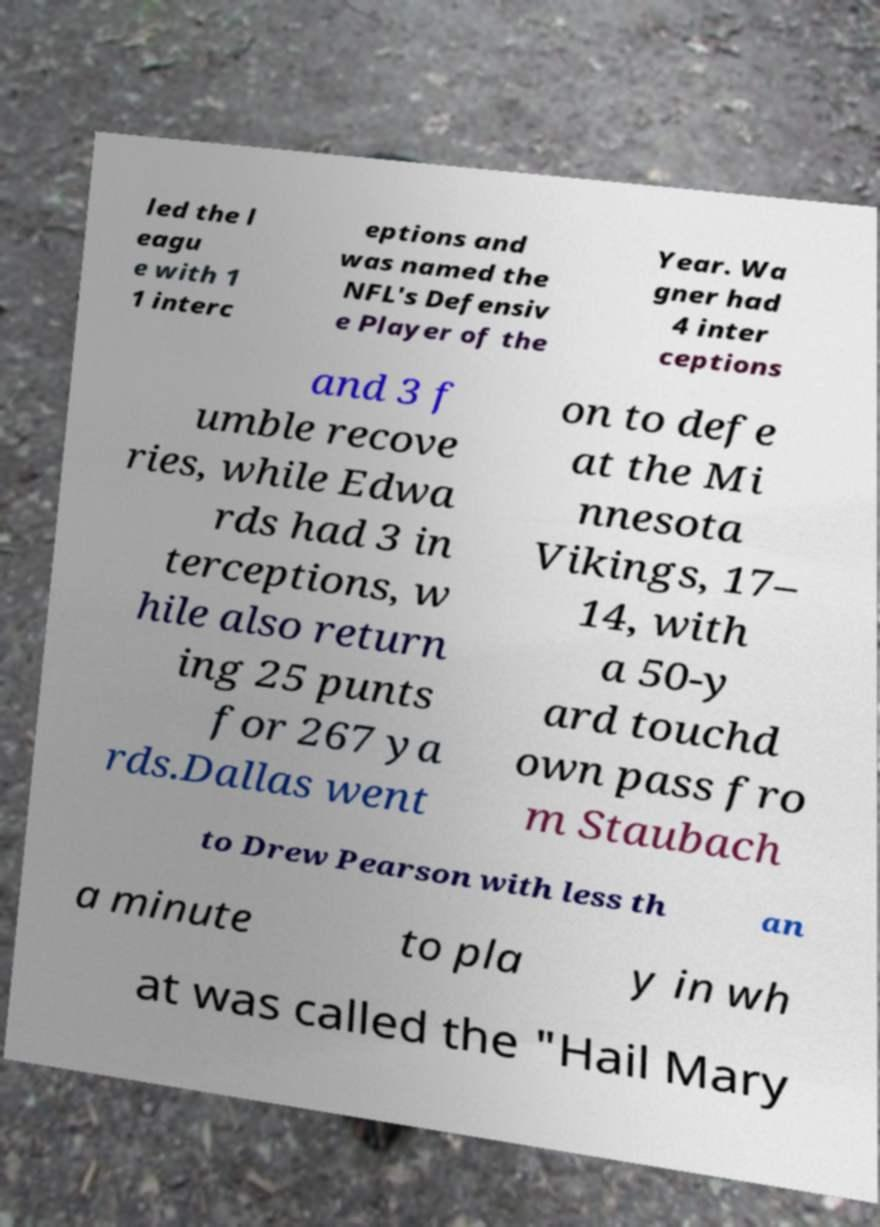Could you assist in decoding the text presented in this image and type it out clearly? led the l eagu e with 1 1 interc eptions and was named the NFL's Defensiv e Player of the Year. Wa gner had 4 inter ceptions and 3 f umble recove ries, while Edwa rds had 3 in terceptions, w hile also return ing 25 punts for 267 ya rds.Dallas went on to defe at the Mi nnesota Vikings, 17– 14, with a 50-y ard touchd own pass fro m Staubach to Drew Pearson with less th an a minute to pla y in wh at was called the "Hail Mary 